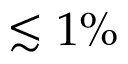<formula> <loc_0><loc_0><loc_500><loc_500>\lesssim 1 \%</formula> 